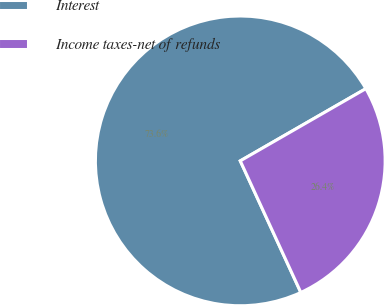Convert chart. <chart><loc_0><loc_0><loc_500><loc_500><pie_chart><fcel>Interest<fcel>Income taxes-net of refunds<nl><fcel>73.56%<fcel>26.44%<nl></chart> 